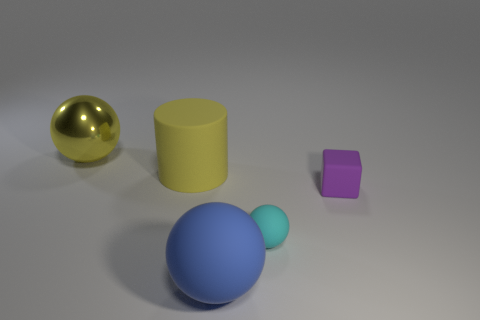There is a large sphere that is left of the large thing in front of the big cylinder; how many big objects are in front of it?
Offer a terse response. 2. There is a sphere behind the tiny cyan rubber object; is its color the same as the large cylinder?
Your response must be concise. Yes. How many other objects are the same shape as the purple rubber thing?
Your response must be concise. 0. How many other objects are the same material as the big yellow ball?
Make the answer very short. 0. There is a ball that is to the left of the big ball that is in front of the rubber thing that is to the right of the tiny ball; what is its material?
Provide a succinct answer. Metal. Is the material of the tiny cyan sphere the same as the yellow sphere?
Keep it short and to the point. No. How many spheres are either purple matte things or yellow matte objects?
Provide a succinct answer. 0. There is a matte sphere right of the big blue ball; what color is it?
Offer a terse response. Cyan. What number of matte things are either tiny objects or small gray cylinders?
Make the answer very short. 2. What material is the sphere that is right of the large sphere on the right side of the large yellow rubber object made of?
Offer a very short reply. Rubber. 